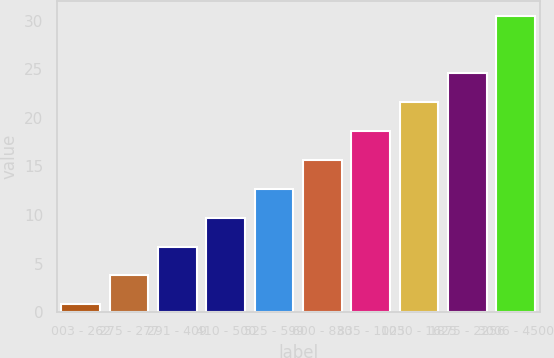Convert chart. <chart><loc_0><loc_0><loc_500><loc_500><bar_chart><fcel>003 - 262<fcel>275 - 277<fcel>291 - 409<fcel>410 - 500<fcel>525 - 599<fcel>600 - 830<fcel>835 - 1025<fcel>1030 - 1625<fcel>1875 - 2256<fcel>3006 - 4500<nl><fcel>0.81<fcel>3.78<fcel>6.75<fcel>9.72<fcel>12.69<fcel>15.66<fcel>18.63<fcel>21.6<fcel>24.57<fcel>30.47<nl></chart> 